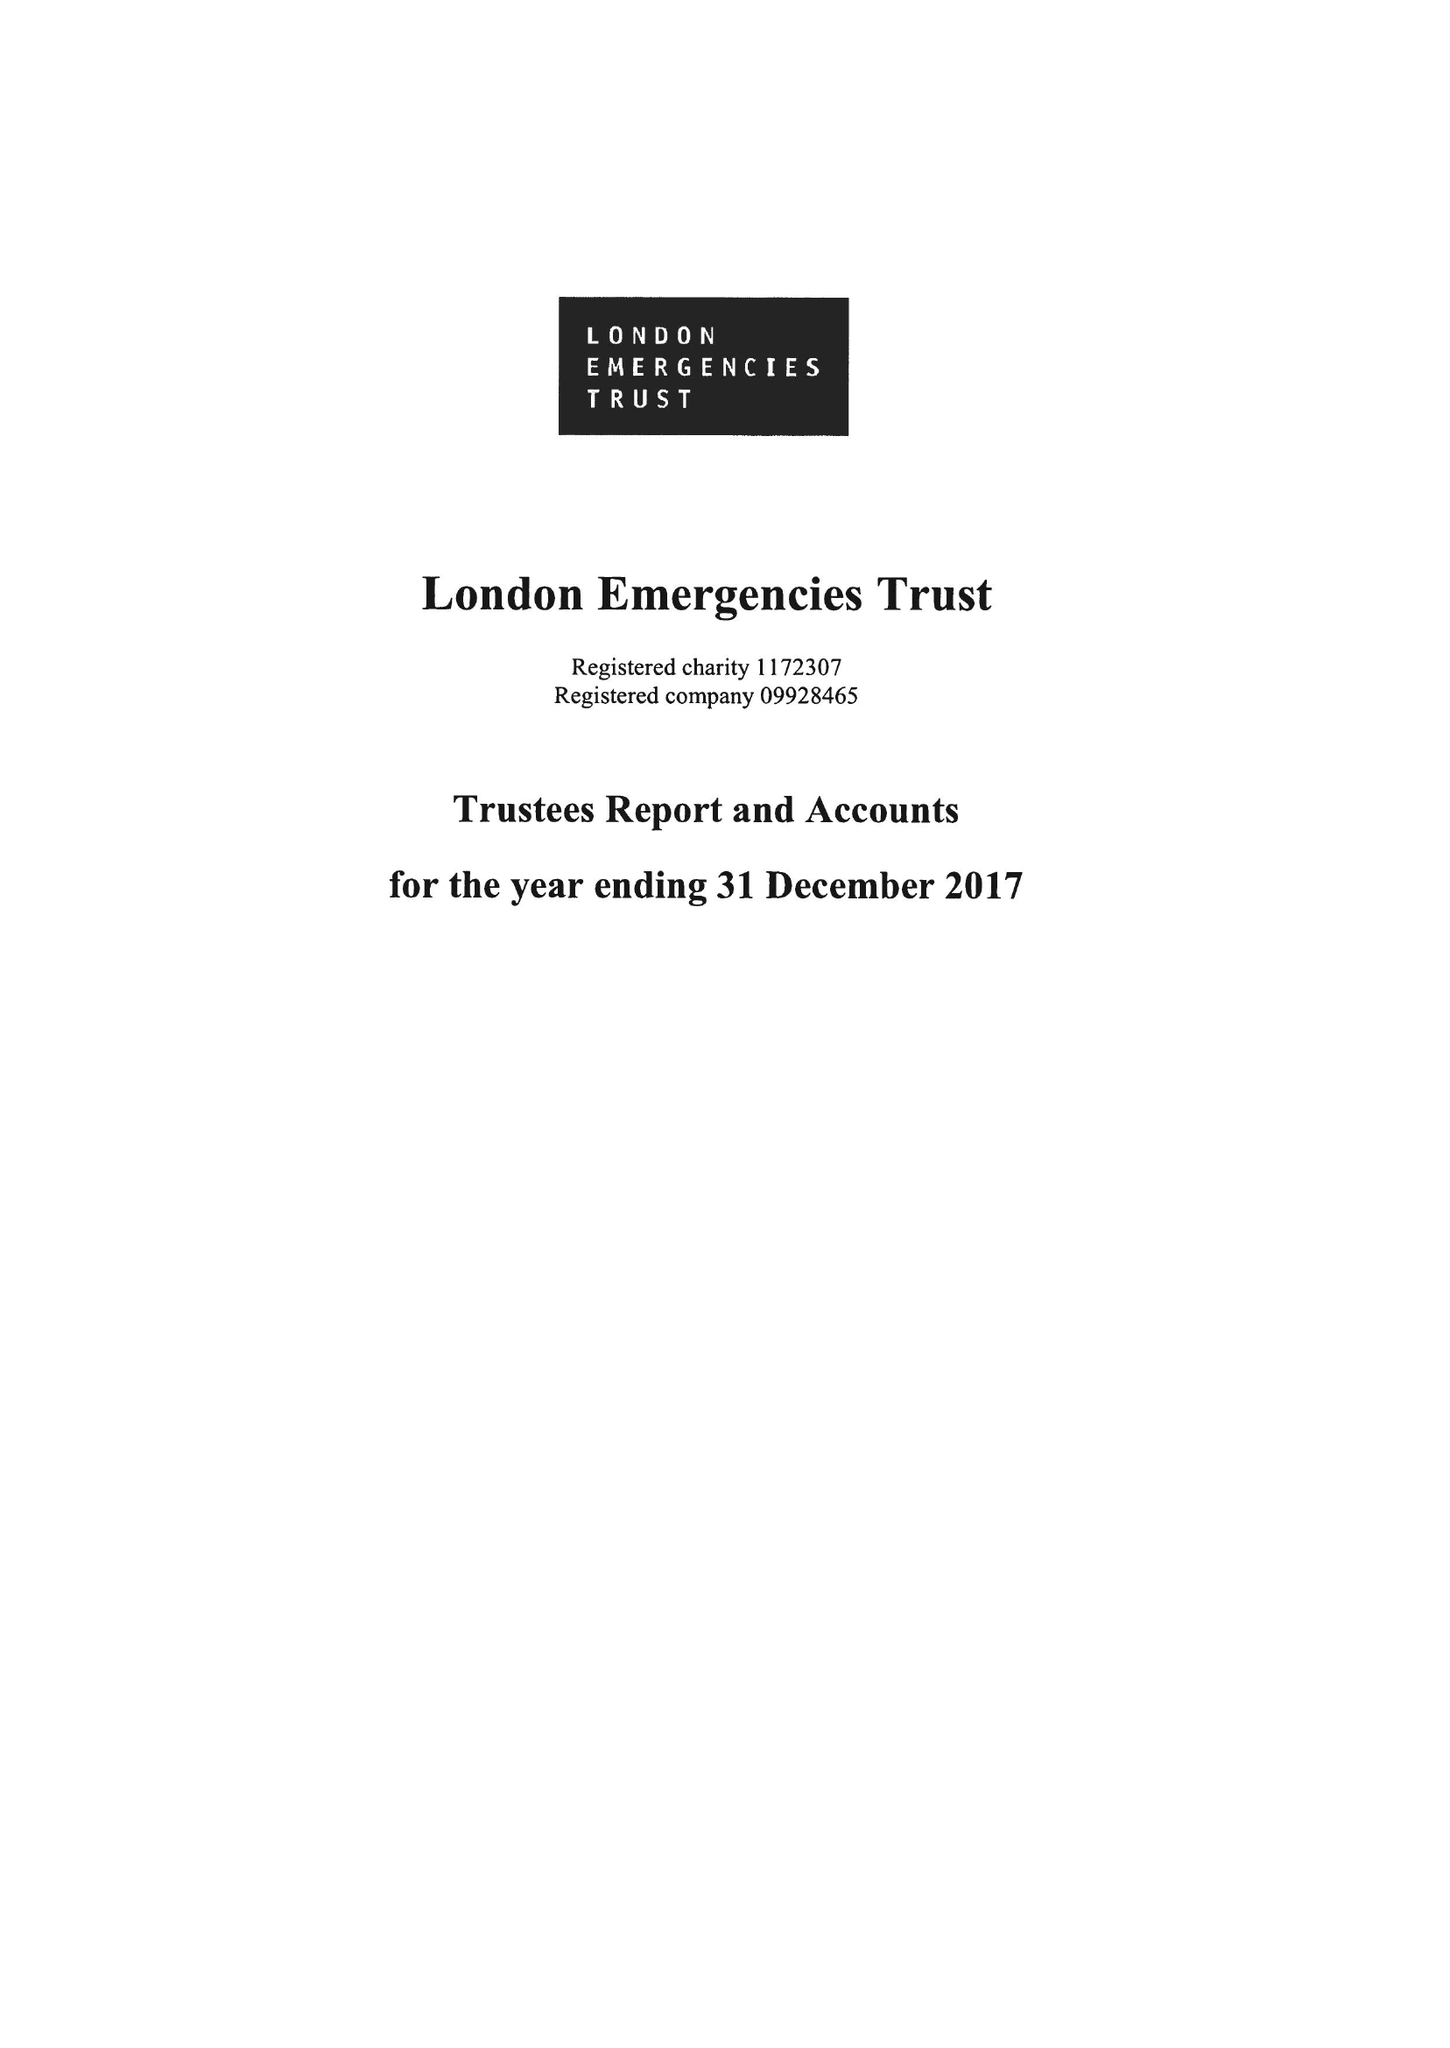What is the value for the income_annually_in_british_pounds?
Answer the question using a single word or phrase. 10465878.00 